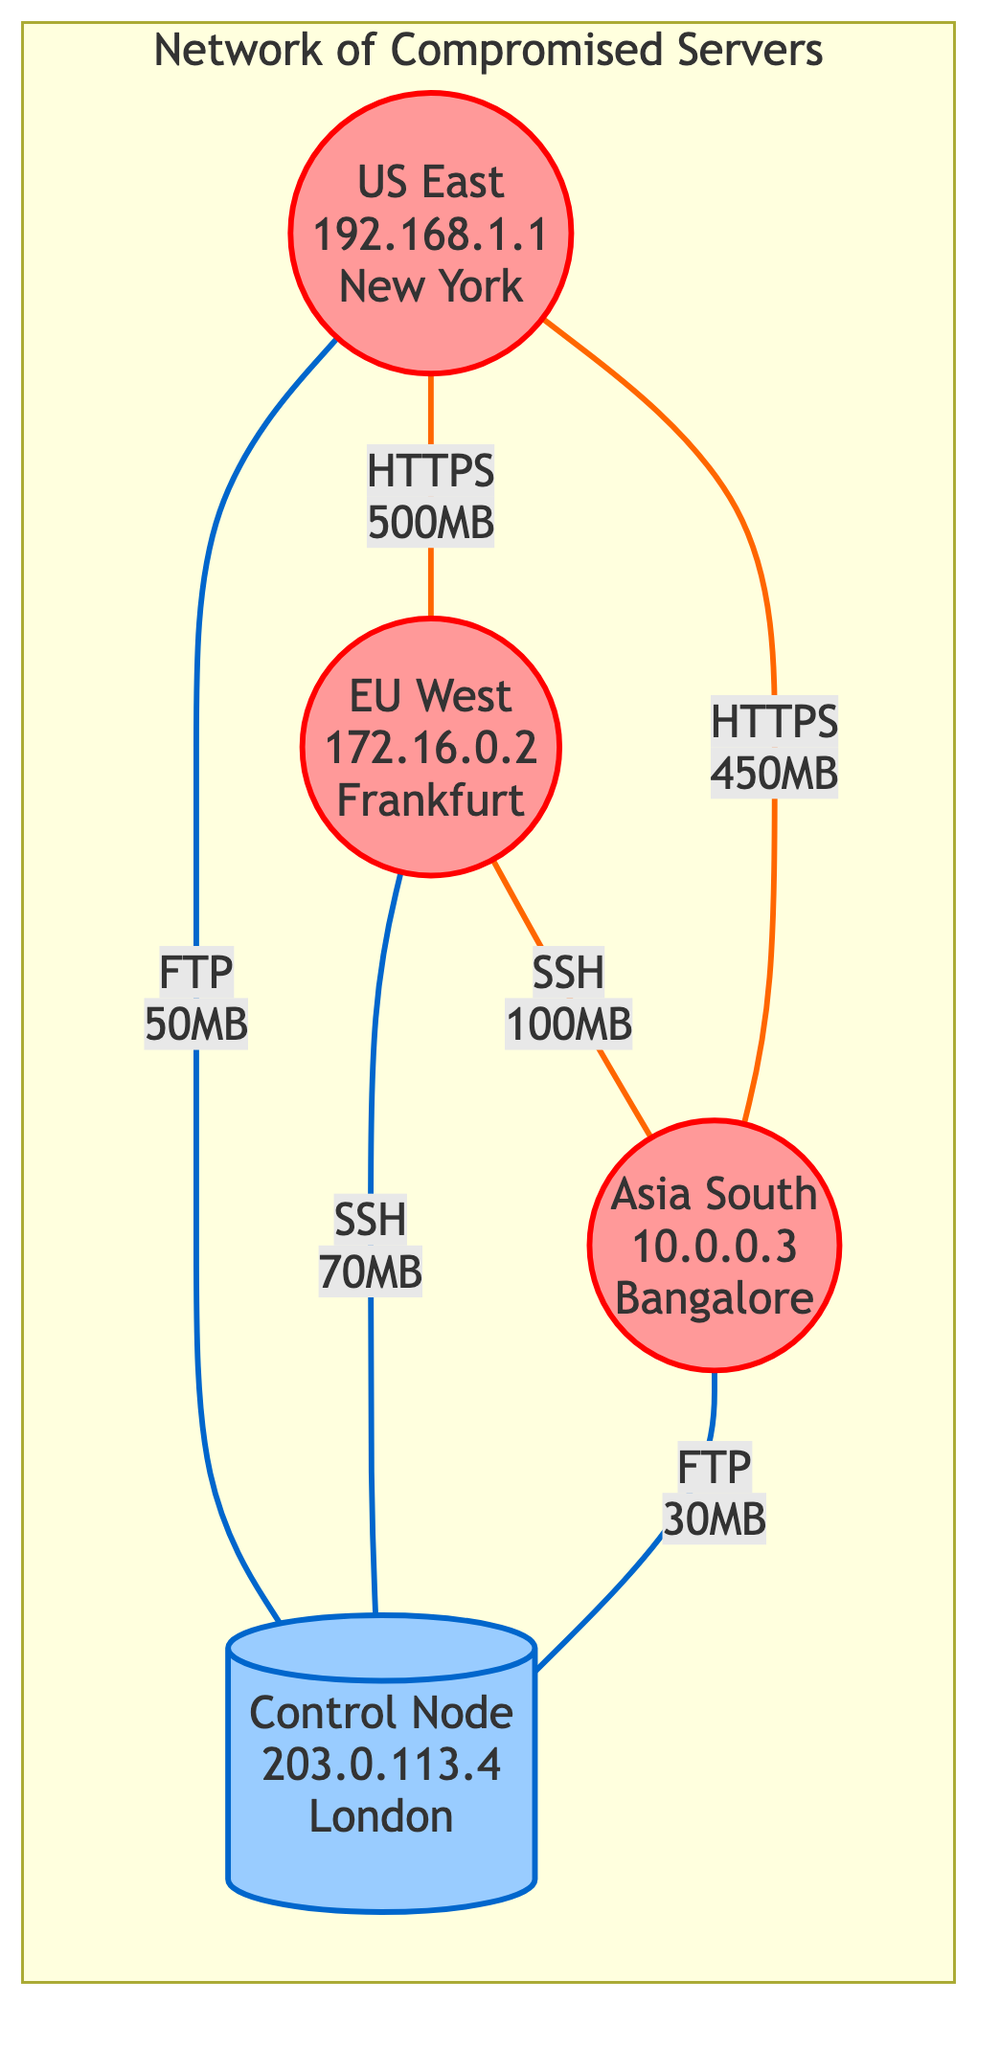What is the IP address of Server1? The diagram lists Server1's information, and under that, it explicitly shows the IP address as 192.168.1.1.
Answer: 192.168.1.1 How many compromised servers are in the network? By counting the nodes classified as compromised, we see there are three: Server1, Server2, and Server3.
Answer: 3 What type of connection exists between Server2 and Server3? The edge connecting Server2 and Server3 is labeled "Command Relay" and indicates the use of the SSH protocol, as shown in the diagram.
Answer: Command Relay Which server has the highest-volume data flow? To determine this, we need to look at the edges connected to each server. The highest data volume is between Server1 and Server2 with 500MB for "Data Exfiltration Path."
Answer: Server1 What is the total data volume transmitted directly to the Control Node? We review the edges connected directly to Server4. Summing the data volumes from Server1 (50MB), Server2 (70MB), and Server3 (30MB) gives a total of 150MB.
Answer: 150MB Which protocol is used for the data exchange between Server1 and Server2? The label on the edge directly connecting Server1 to Server2 shows that they communicate using the HTTPS protocol.
Answer: HTTPS What is the location of the Control Node? The diagram provides information on the Control Node, indicating its location as London, UK.
Answer: London, UK Which server receives the most data exfiltration? By analyzing the edges, Server1 receives data exfiltration from Server3 (450MB) and sends to Server2 (500MB), making it the server with the greatest data movement in terms of volume.
Answer: Server1 How many connections does Server3 have? Checking the edges connected to Server3, we see it connects to both Server2 and Server4, resulting in a total of two connections.
Answer: 2 